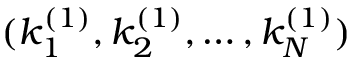<formula> <loc_0><loc_0><loc_500><loc_500>( k _ { 1 } ^ { ( 1 ) } , k _ { 2 } ^ { ( 1 ) } , \dots , k _ { N } ^ { ( 1 ) } )</formula> 